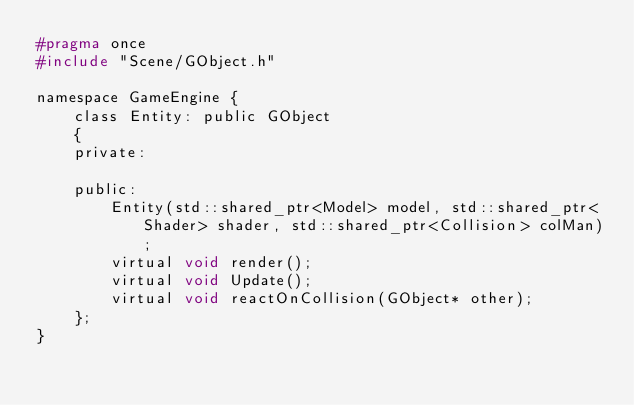Convert code to text. <code><loc_0><loc_0><loc_500><loc_500><_C_>#pragma once
#include "Scene/GObject.h"

namespace GameEngine {
	class Entity: public GObject
	{
	private:

	public:
		Entity(std::shared_ptr<Model> model, std::shared_ptr<Shader> shader, std::shared_ptr<Collision> colMan);
		virtual void render();
		virtual void Update();
		virtual void reactOnCollision(GObject* other);
	};
}

</code> 